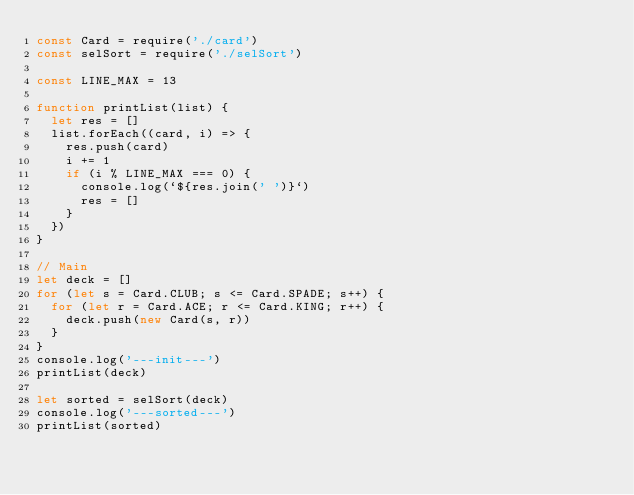<code> <loc_0><loc_0><loc_500><loc_500><_JavaScript_>const Card = require('./card')
const selSort = require('./selSort')

const LINE_MAX = 13

function printList(list) {
  let res = []
  list.forEach((card, i) => {
    res.push(card)
    i += 1
    if (i % LINE_MAX === 0) {
      console.log(`${res.join(' ')}`)
      res = []
    }
  })
}

// Main
let deck = []
for (let s = Card.CLUB; s <= Card.SPADE; s++) {
  for (let r = Card.ACE; r <= Card.KING; r++) {
    deck.push(new Card(s, r))
  }
}
console.log('---init---')
printList(deck)

let sorted = selSort(deck)
console.log('---sorted---')
printList(sorted)
</code> 